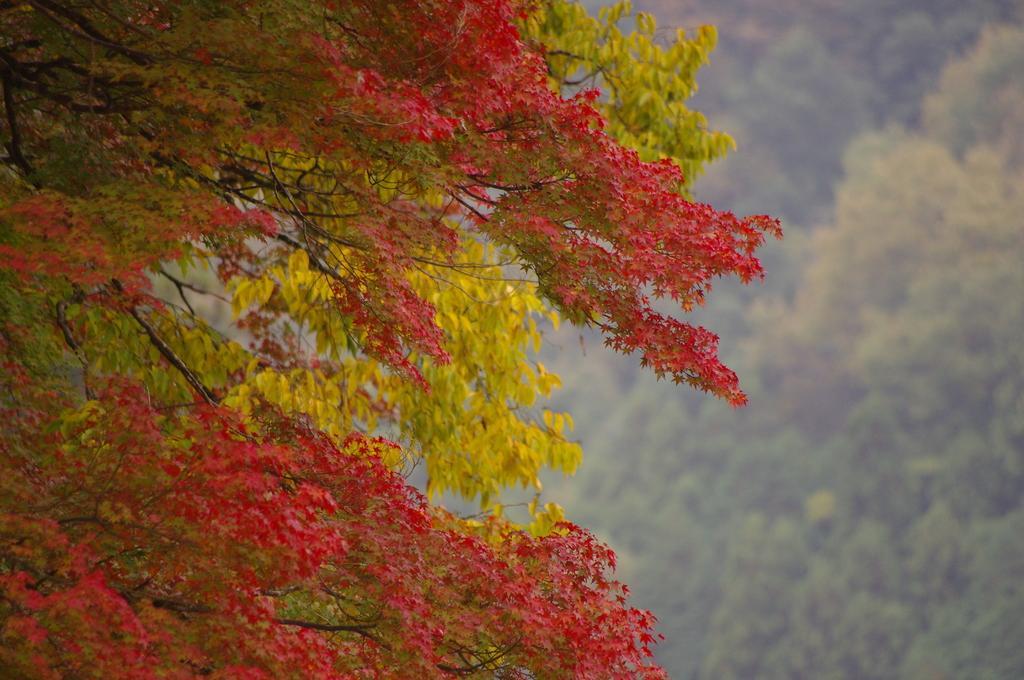Please provide a concise description of this image. In this image in the foreground there are some trees, and in the background also there are trees. 